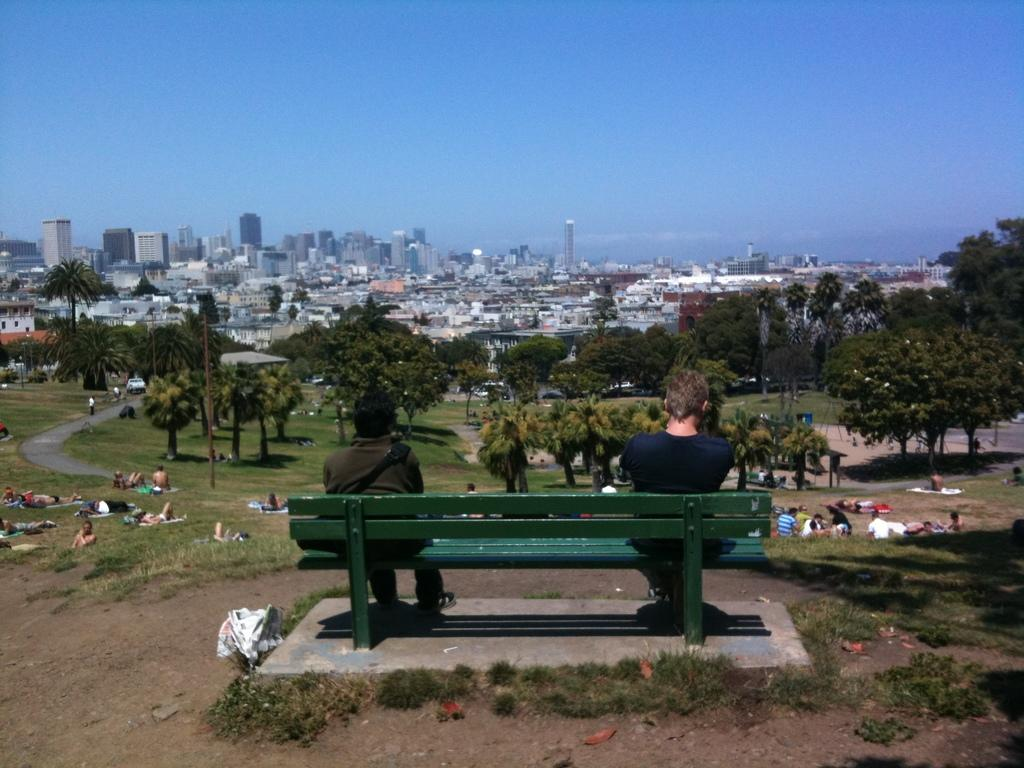How many people are sitting on the green bench in the image? There are two persons sitting on a green bench in the image. What can be seen in front of the persons sitting on the bench? There is a group of people and trees in front of them. Are there any structures visible in the image? Yes, there are buildings in front of them. What type of fruit is being held by the rabbit in the image? There is no rabbit present in the image, and therefore no fruit being held by a rabbit. 